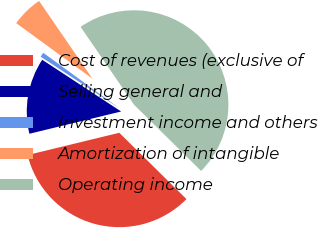<chart> <loc_0><loc_0><loc_500><loc_500><pie_chart><fcel>Cost of revenues (exclusive of<fcel>Selling general and<fcel>Investment income and others<fcel>Amortization of intangible<fcel>Operating income<nl><fcel>33.81%<fcel>13.02%<fcel>0.79%<fcel>5.4%<fcel>46.97%<nl></chart> 